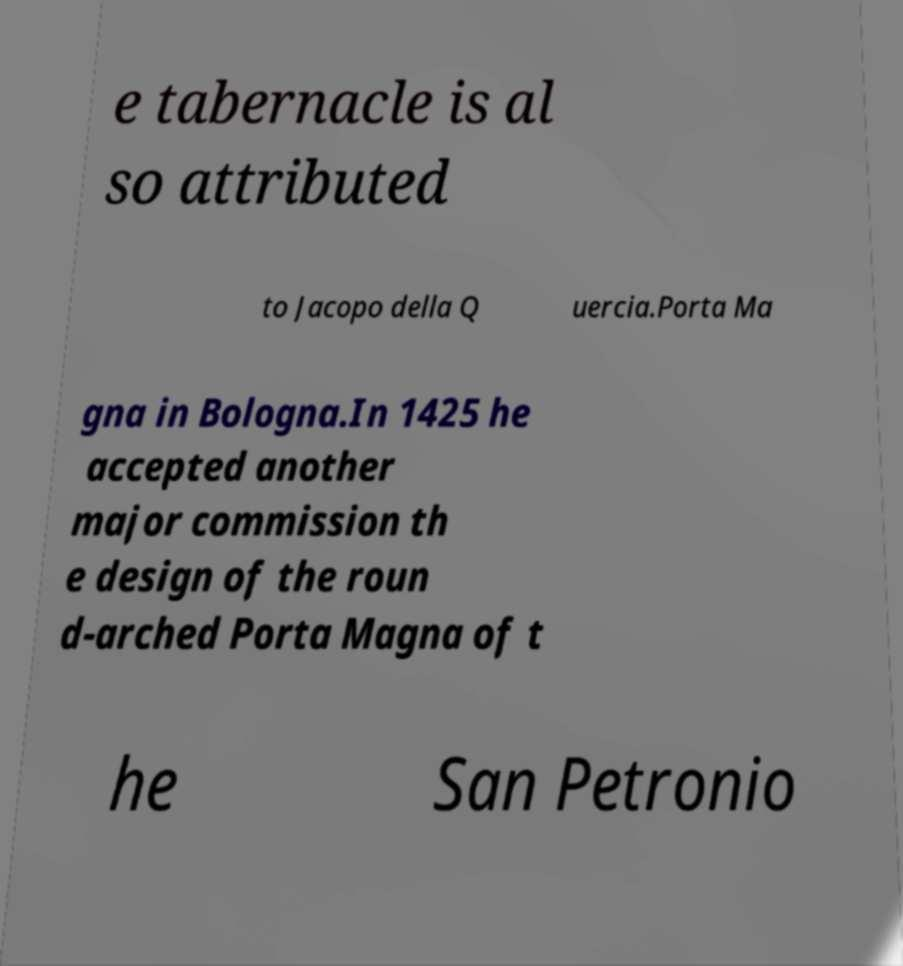For documentation purposes, I need the text within this image transcribed. Could you provide that? e tabernacle is al so attributed to Jacopo della Q uercia.Porta Ma gna in Bologna.In 1425 he accepted another major commission th e design of the roun d-arched Porta Magna of t he San Petronio 